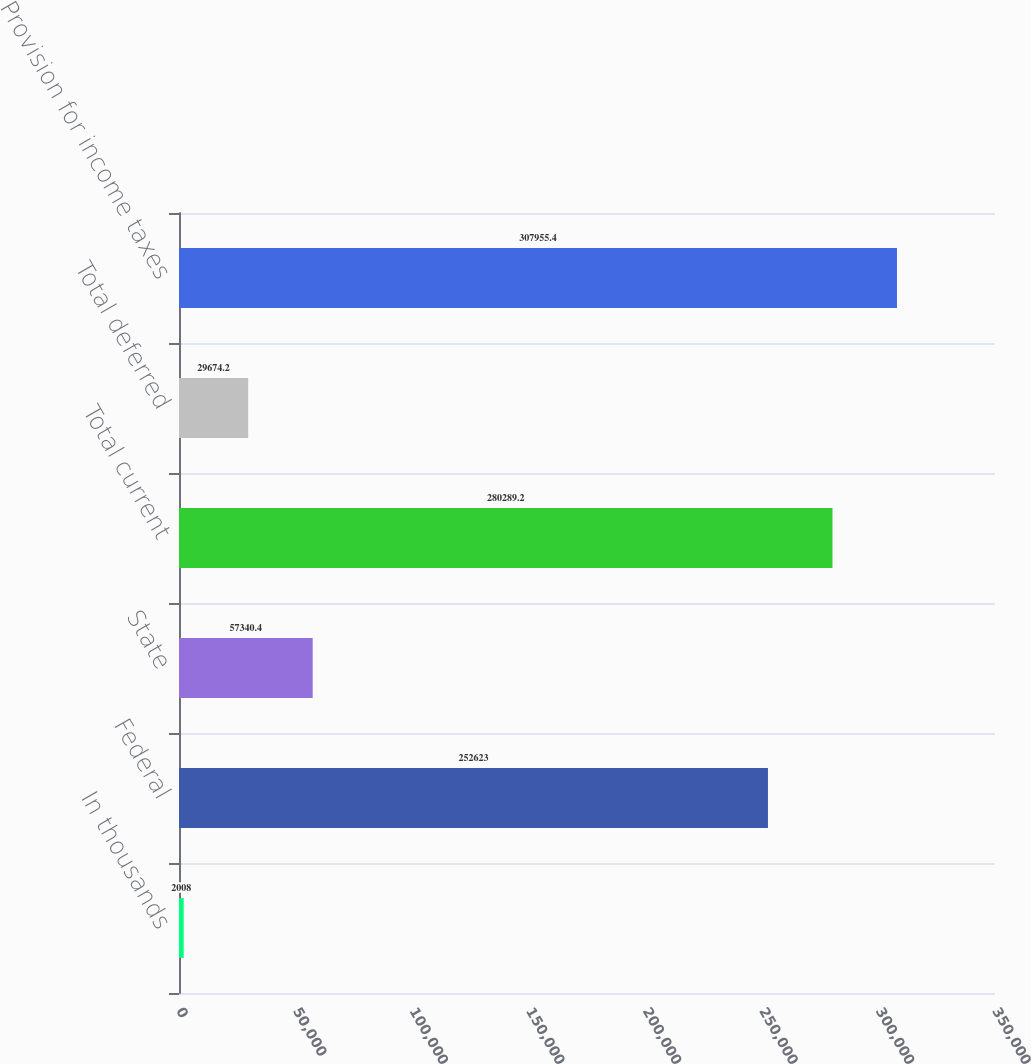Convert chart. <chart><loc_0><loc_0><loc_500><loc_500><bar_chart><fcel>In thousands<fcel>Federal<fcel>State<fcel>Total current<fcel>Total deferred<fcel>Provision for income taxes<nl><fcel>2008<fcel>252623<fcel>57340.4<fcel>280289<fcel>29674.2<fcel>307955<nl></chart> 